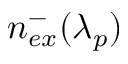<formula> <loc_0><loc_0><loc_500><loc_500>n _ { e x } ^ { - } ( \lambda _ { p } )</formula> 